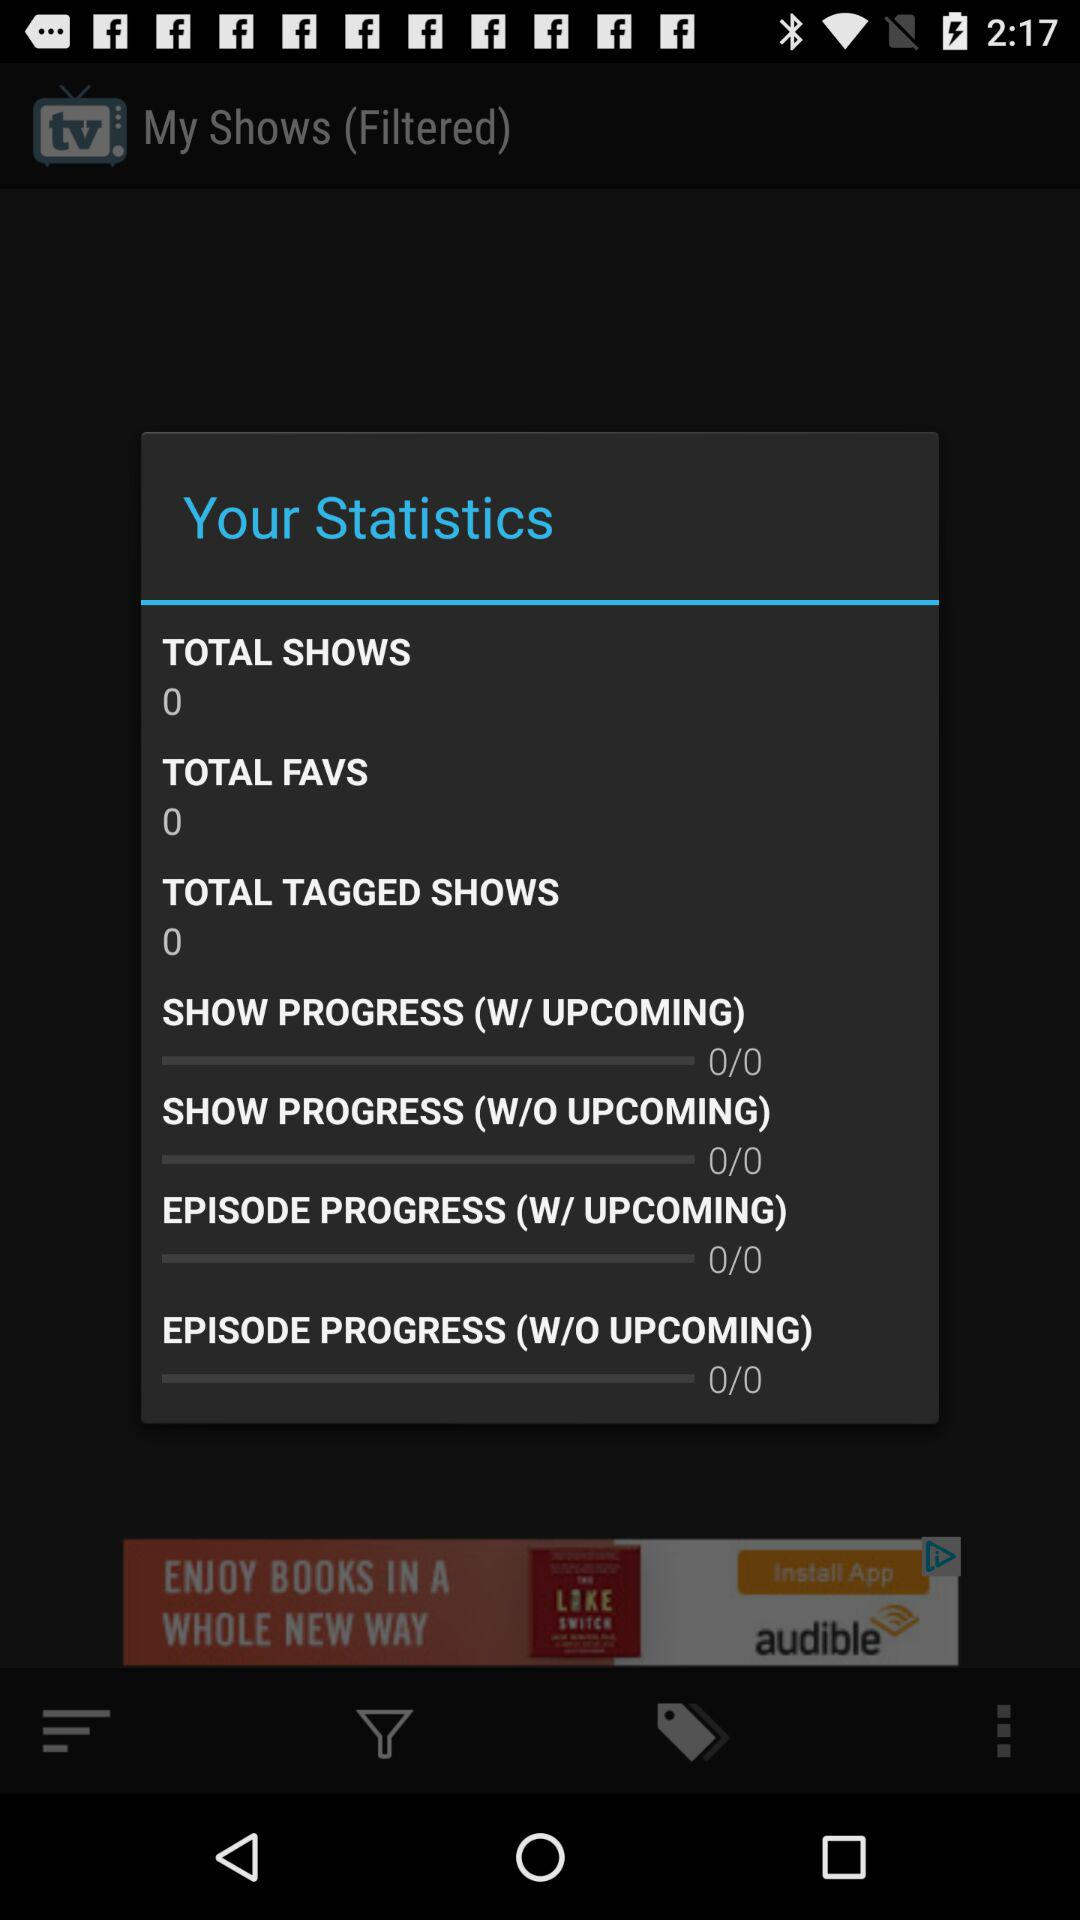What is the number of "TOTAL TAGGED SHOWS"? The number of "TOTAL TAGGED SHOWS" is 0. 